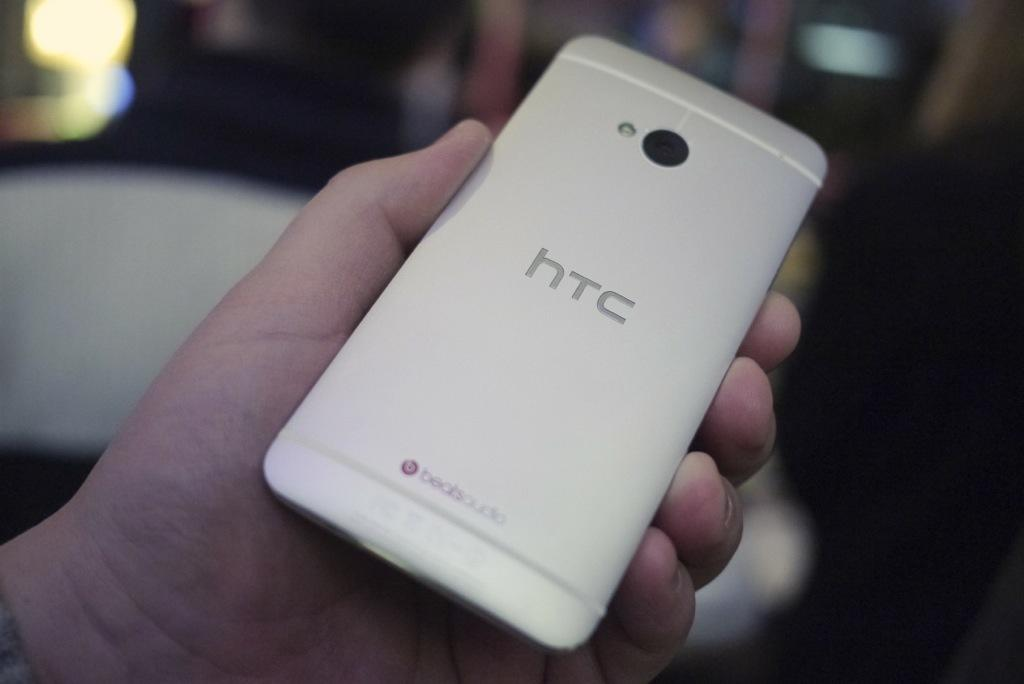<image>
Give a short and clear explanation of the subsequent image. a person is holding a white HTC phone 